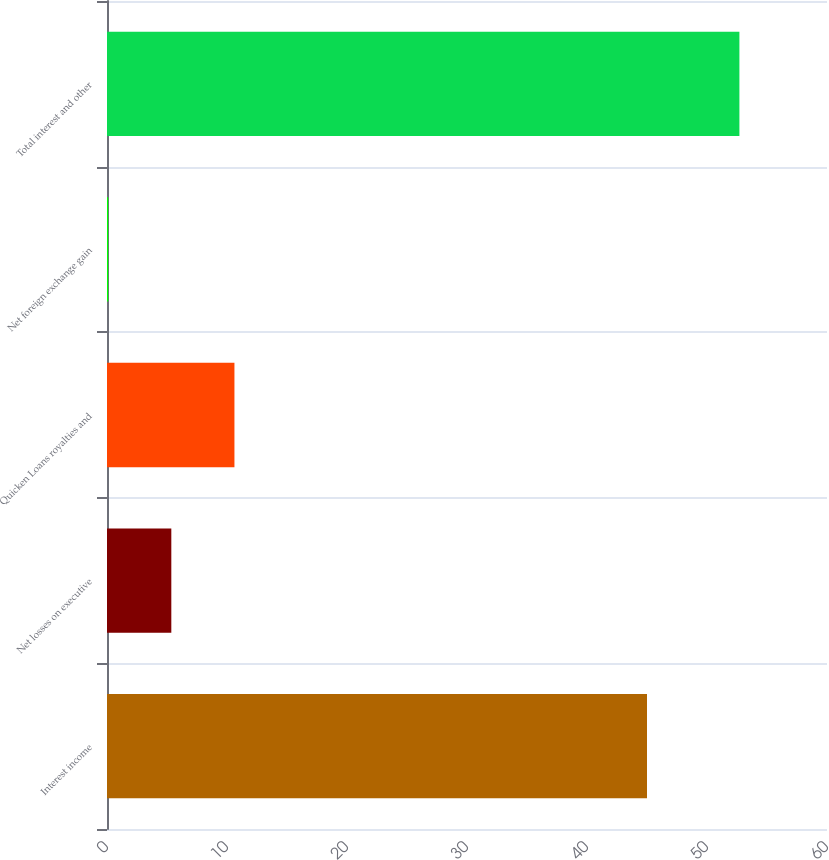<chart> <loc_0><loc_0><loc_500><loc_500><bar_chart><fcel>Interest income<fcel>Net losses on executive<fcel>Quicken Loans royalties and<fcel>Net foreign exchange gain<fcel>Total interest and other<nl><fcel>45<fcel>5.36<fcel>10.62<fcel>0.1<fcel>52.7<nl></chart> 